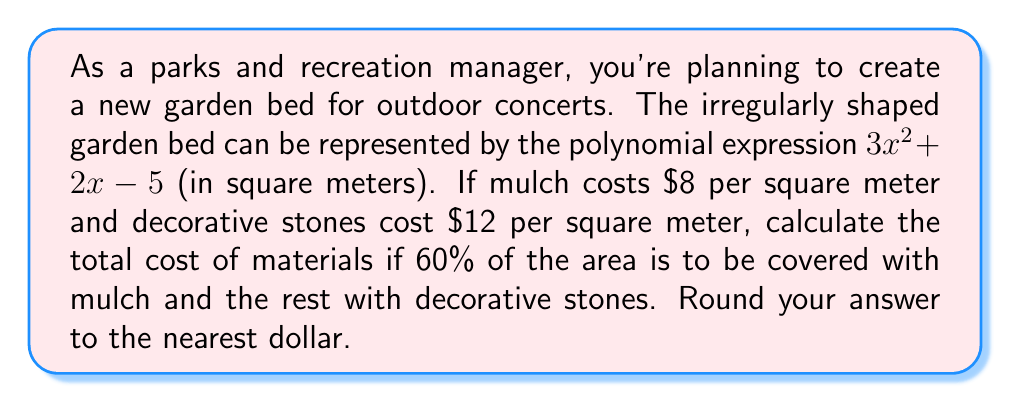Can you answer this question? Let's approach this step-by-step:

1) First, we need to find the total area of the garden bed. The area is given by the polynomial $3x^2 + 2x - 5$ square meters.

2) To calculate the actual area, we need to evaluate this polynomial at a specific value of x. However, no value for x is given, so we'll use a variable approach.

3) Let's call the total area A. So, $A = 3x^2 + 2x - 5$ sq m

4) Now, we need to calculate the areas for mulch and decorative stones:
   - Mulch area = 60% of A = $0.6A = 0.6(3x^2 + 2x - 5)$ sq m
   - Stone area = 40% of A = $0.4A = 0.4(3x^2 + 2x - 5)$ sq m

5) Next, let's calculate the cost for each:
   - Mulch cost = $8 * 0.6(3x^2 + 2x - 5) = 4.8x^2 + 1.6x - 24$ dollars
   - Stone cost = $12 * 0.4(3x^2 + 2x - 5) = 14.4x^2 + 4.8x - 24$ dollars

6) Total cost = Mulch cost + Stone cost
   $= (4.8x^2 + 1.6x - 24) + (14.4x^2 + 4.8x - 24)$
   $= 19.2x^2 + 6.4x - 48$ dollars

This is the polynomial expression for the total cost in terms of x.
Answer: The total cost of materials is given by the polynomial expression: $19.2x^2 + 6.4x - 48$ dollars, where x is the dimension of the garden bed. 